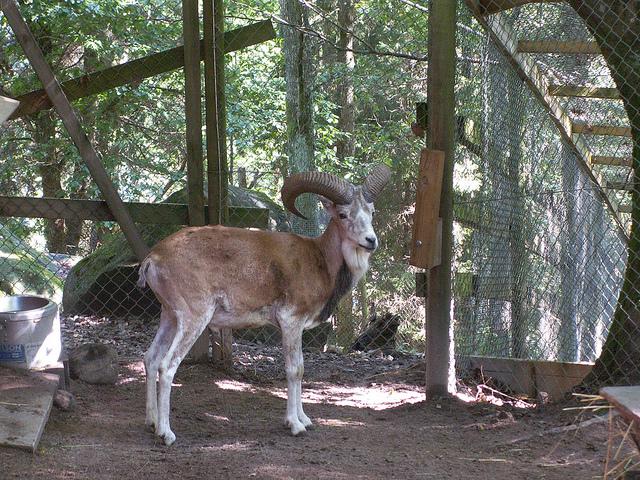Where are the trees?
Give a very brief answer. Background. Is this animal a male or a female?
Be succinct. Male. Is this in a zoo?
Keep it brief. Yes. 